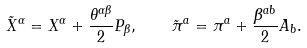Convert formula to latex. <formula><loc_0><loc_0><loc_500><loc_500>\tilde { X } ^ { \alpha } = X ^ { \alpha } + \frac { \theta ^ { \alpha \beta } } { 2 } P _ { \beta } , \quad \tilde { \pi } ^ { a } = \pi ^ { a } + \frac { \beta ^ { a b } } { 2 } A _ { b } .</formula> 